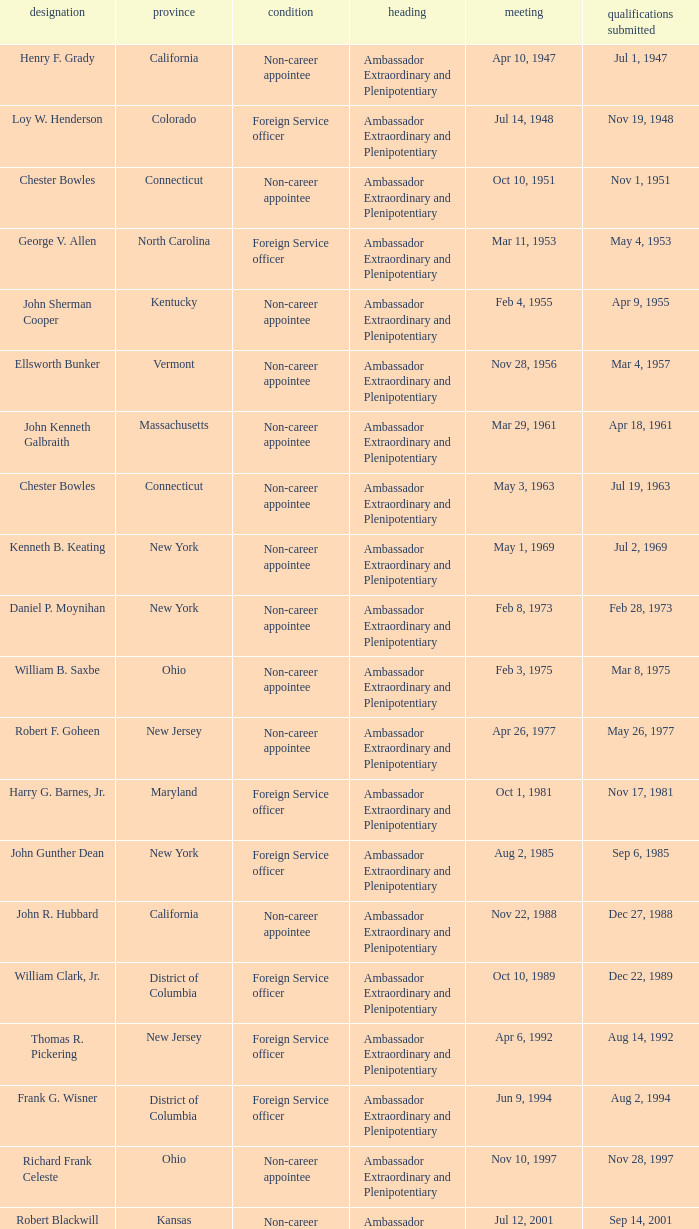What state has an appointment for jul 12, 2001? Kansas. 